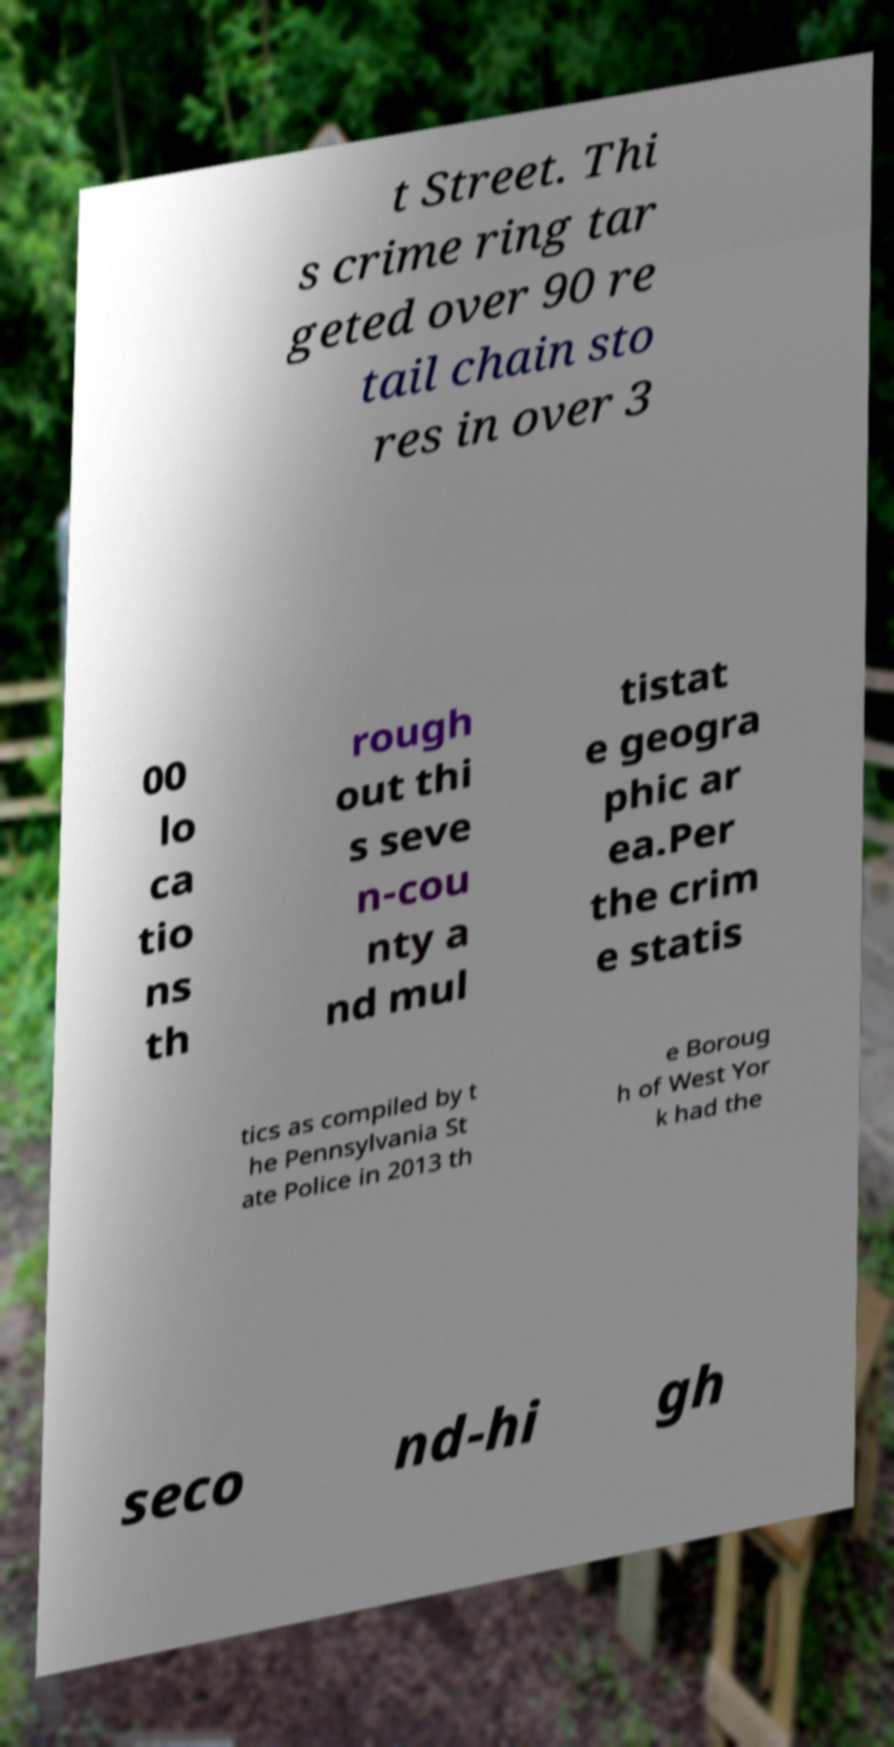There's text embedded in this image that I need extracted. Can you transcribe it verbatim? t Street. Thi s crime ring tar geted over 90 re tail chain sto res in over 3 00 lo ca tio ns th rough out thi s seve n-cou nty a nd mul tistat e geogra phic ar ea.Per the crim e statis tics as compiled by t he Pennsylvania St ate Police in 2013 th e Boroug h of West Yor k had the seco nd-hi gh 